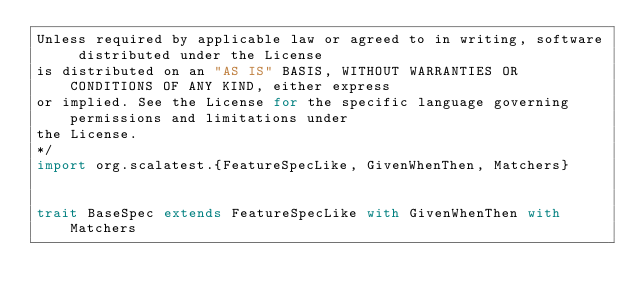Convert code to text. <code><loc_0><loc_0><loc_500><loc_500><_Scala_>Unless required by applicable law or agreed to in writing, software distributed under the License
is distributed on an "AS IS" BASIS, WITHOUT WARRANTIES OR CONDITIONS OF ANY KIND, either express
or implied. See the License for the specific language governing permissions and limitations under
the License.
*/
import org.scalatest.{FeatureSpecLike, GivenWhenThen, Matchers}


trait BaseSpec extends FeatureSpecLike with GivenWhenThen with Matchers
</code> 